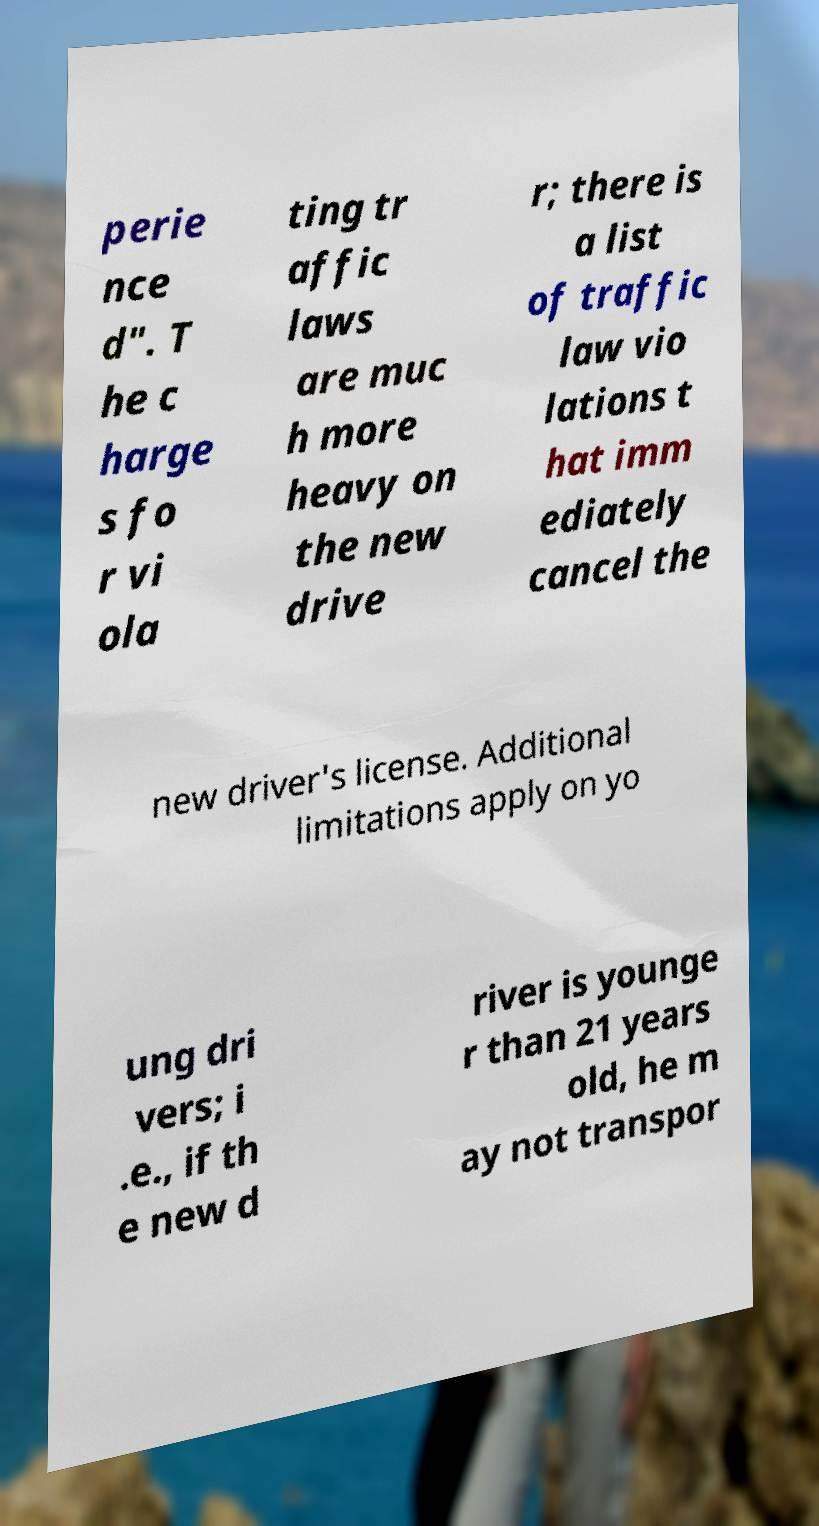There's text embedded in this image that I need extracted. Can you transcribe it verbatim? perie nce d". T he c harge s fo r vi ola ting tr affic laws are muc h more heavy on the new drive r; there is a list of traffic law vio lations t hat imm ediately cancel the new driver's license. Additional limitations apply on yo ung dri vers; i .e., if th e new d river is younge r than 21 years old, he m ay not transpor 